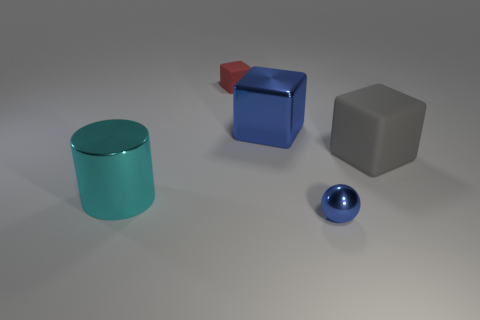Add 2 gray cubes. How many objects exist? 7 Subtract all blue blocks. How many blocks are left? 2 Subtract all balls. How many objects are left? 4 Subtract 3 blocks. How many blocks are left? 0 Add 1 large red cylinders. How many large red cylinders exist? 1 Subtract 0 yellow blocks. How many objects are left? 5 Subtract all yellow blocks. Subtract all green cylinders. How many blocks are left? 3 Subtract all red cubes. How many yellow balls are left? 0 Subtract all cylinders. Subtract all big metal cylinders. How many objects are left? 3 Add 1 small shiny things. How many small shiny things are left? 2 